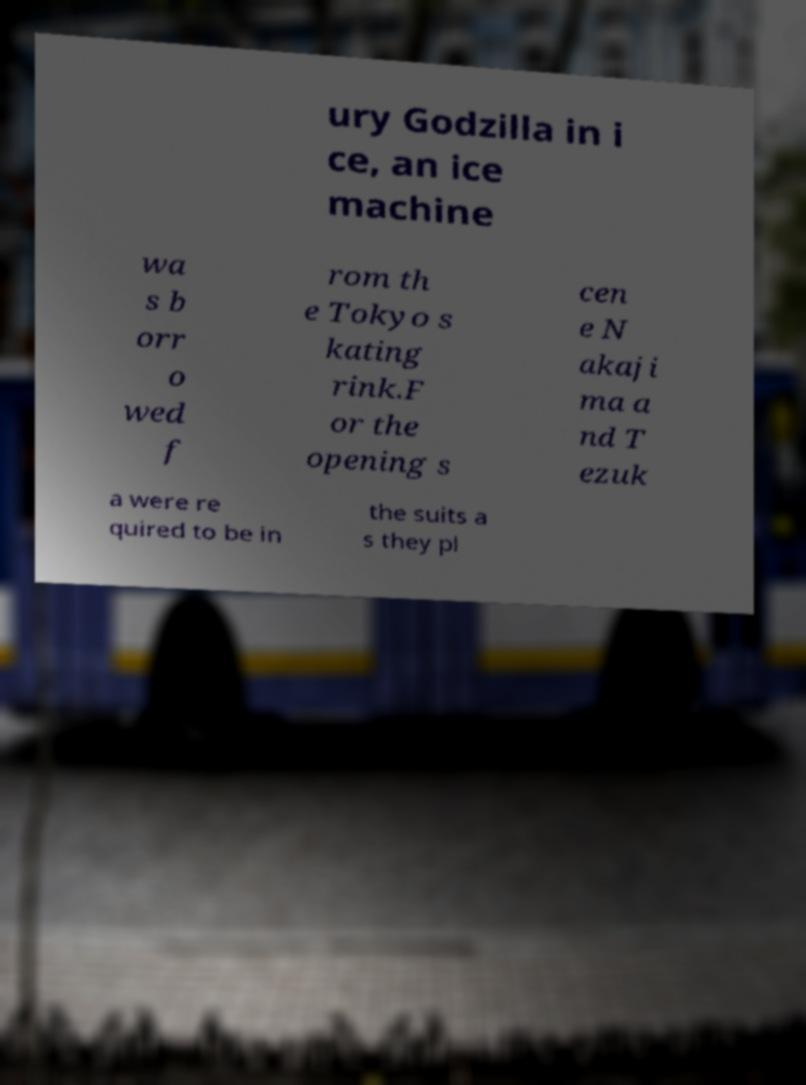Can you accurately transcribe the text from the provided image for me? ury Godzilla in i ce, an ice machine wa s b orr o wed f rom th e Tokyo s kating rink.F or the opening s cen e N akaji ma a nd T ezuk a were re quired to be in the suits a s they pl 